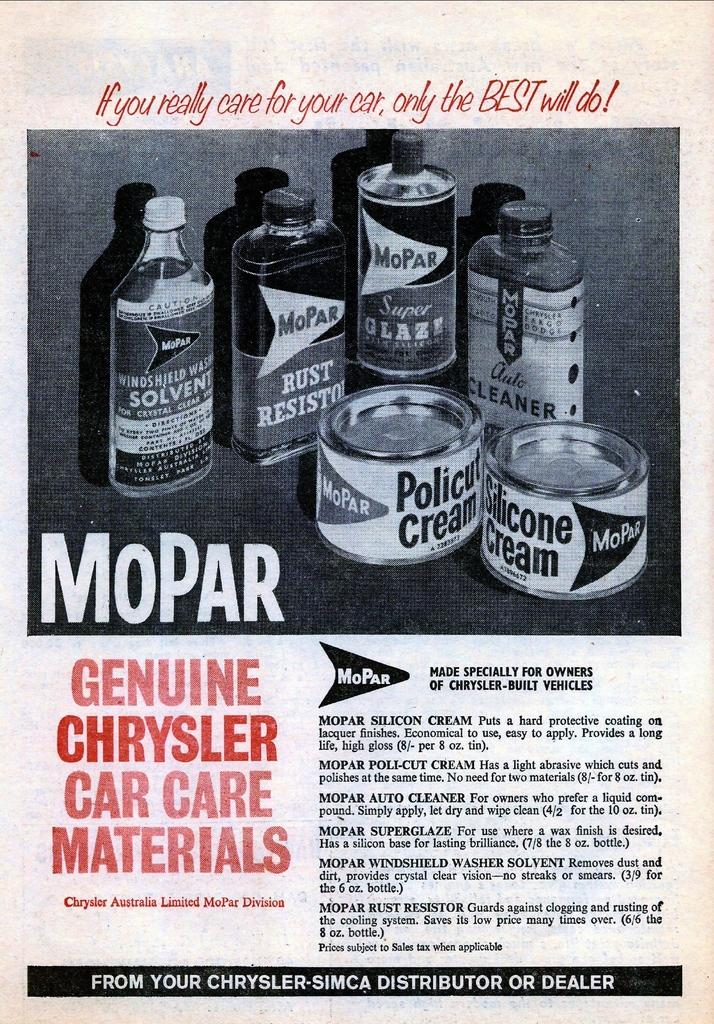<image>
Give a short and clear explanation of the subsequent image. An old ad for MoPar says their products are made specially for owners of Chryslers. 